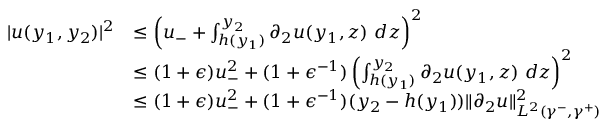Convert formula to latex. <formula><loc_0><loc_0><loc_500><loc_500>\begin{array} { r l } { | u ( y _ { 1 } , y _ { 2 } ) | ^ { 2 } } & { \leq \left ( u _ { - } + \int _ { h ( y _ { 1 } ) } ^ { y _ { 2 } } \partial _ { 2 } u ( y _ { 1 } , z ) \ d z \right ) ^ { 2 } } \\ & { \leq ( 1 + \epsilon ) u _ { - } ^ { 2 } + ( 1 + \epsilon ^ { - 1 } ) \left ( \int _ { h ( y _ { 1 } ) } ^ { y _ { 2 } } \partial _ { 2 } u ( y _ { 1 } , z ) \ d z \right ) ^ { 2 } } \\ & { \leq ( 1 + \epsilon ) u _ { - } ^ { 2 } + ( 1 + \epsilon ^ { - 1 } ) ( y _ { 2 } - h ( y _ { 1 } ) ) \| \partial _ { 2 } u \| _ { L ^ { 2 } ( \gamma ^ { - } , \gamma ^ { + } ) } ^ { 2 } } \end{array}</formula> 